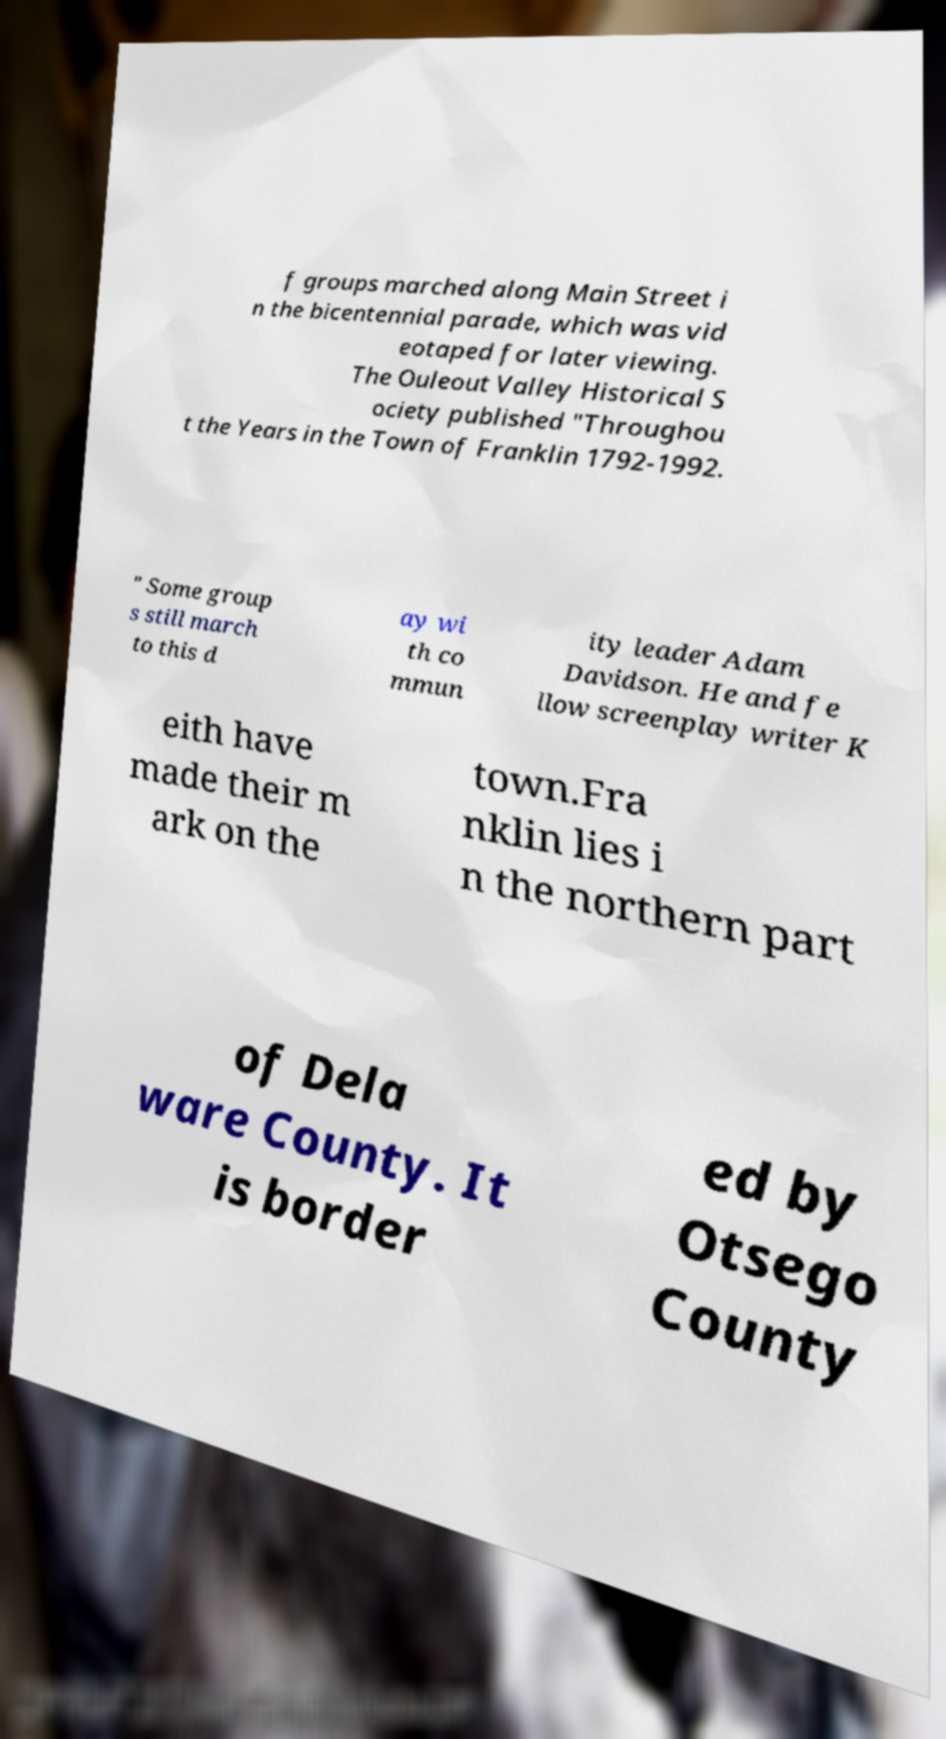Please identify and transcribe the text found in this image. f groups marched along Main Street i n the bicentennial parade, which was vid eotaped for later viewing. The Ouleout Valley Historical S ociety published "Throughou t the Years in the Town of Franklin 1792-1992. " Some group s still march to this d ay wi th co mmun ity leader Adam Davidson. He and fe llow screenplay writer K eith have made their m ark on the town.Fra nklin lies i n the northern part of Dela ware County. It is border ed by Otsego County 